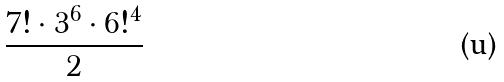Convert formula to latex. <formula><loc_0><loc_0><loc_500><loc_500>\frac { 7 ! \cdot 3 ^ { 6 } \cdot 6 ! ^ { 4 } } { 2 }</formula> 